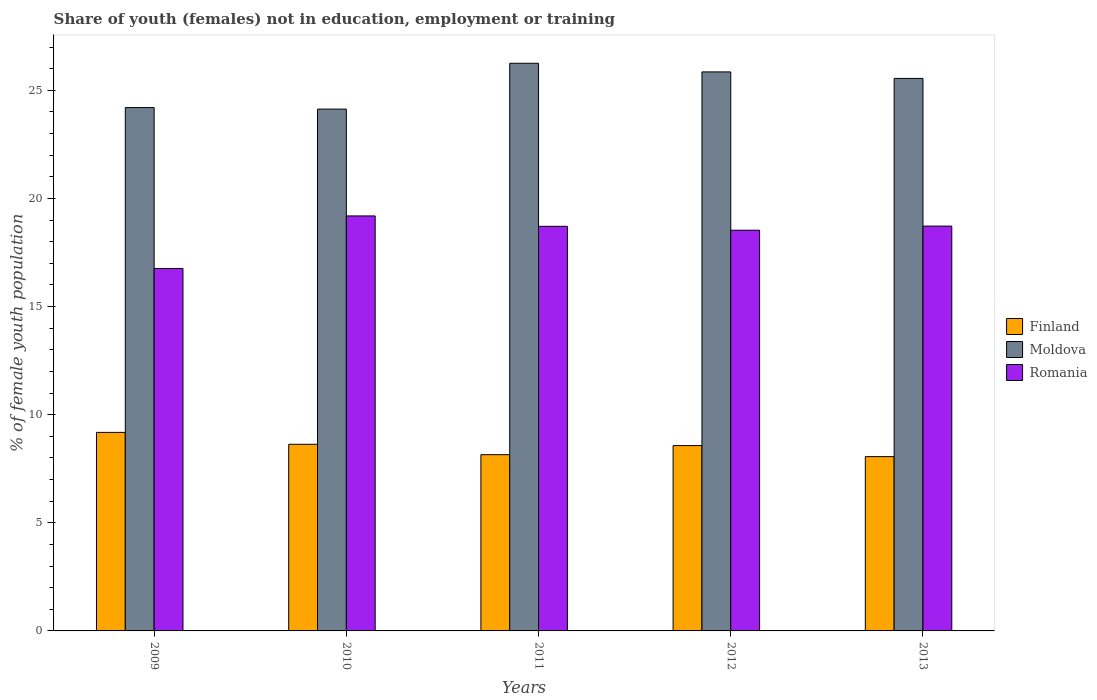How many groups of bars are there?
Your response must be concise. 5. How many bars are there on the 5th tick from the left?
Offer a terse response. 3. How many bars are there on the 3rd tick from the right?
Make the answer very short. 3. What is the percentage of unemployed female population in in Moldova in 2013?
Ensure brevity in your answer.  25.55. Across all years, what is the maximum percentage of unemployed female population in in Finland?
Offer a very short reply. 9.18. Across all years, what is the minimum percentage of unemployed female population in in Moldova?
Provide a succinct answer. 24.13. In which year was the percentage of unemployed female population in in Finland maximum?
Ensure brevity in your answer.  2009. In which year was the percentage of unemployed female population in in Moldova minimum?
Provide a short and direct response. 2010. What is the total percentage of unemployed female population in in Romania in the graph?
Provide a succinct answer. 91.91. What is the difference between the percentage of unemployed female population in in Finland in 2011 and that in 2012?
Ensure brevity in your answer.  -0.42. What is the difference between the percentage of unemployed female population in in Moldova in 2010 and the percentage of unemployed female population in in Finland in 2009?
Offer a very short reply. 14.95. What is the average percentage of unemployed female population in in Finland per year?
Offer a very short reply. 8.52. In the year 2010, what is the difference between the percentage of unemployed female population in in Romania and percentage of unemployed female population in in Moldova?
Offer a very short reply. -4.94. What is the ratio of the percentage of unemployed female population in in Finland in 2009 to that in 2012?
Keep it short and to the point. 1.07. Is the difference between the percentage of unemployed female population in in Romania in 2012 and 2013 greater than the difference between the percentage of unemployed female population in in Moldova in 2012 and 2013?
Your answer should be very brief. No. What is the difference between the highest and the second highest percentage of unemployed female population in in Romania?
Offer a terse response. 0.47. What is the difference between the highest and the lowest percentage of unemployed female population in in Romania?
Your response must be concise. 2.43. In how many years, is the percentage of unemployed female population in in Romania greater than the average percentage of unemployed female population in in Romania taken over all years?
Keep it short and to the point. 4. Is the sum of the percentage of unemployed female population in in Moldova in 2011 and 2013 greater than the maximum percentage of unemployed female population in in Romania across all years?
Provide a succinct answer. Yes. What does the 3rd bar from the right in 2012 represents?
Your answer should be very brief. Finland. Is it the case that in every year, the sum of the percentage of unemployed female population in in Romania and percentage of unemployed female population in in Moldova is greater than the percentage of unemployed female population in in Finland?
Give a very brief answer. Yes. Are all the bars in the graph horizontal?
Ensure brevity in your answer.  No. How many years are there in the graph?
Ensure brevity in your answer.  5. What is the difference between two consecutive major ticks on the Y-axis?
Provide a succinct answer. 5. Are the values on the major ticks of Y-axis written in scientific E-notation?
Give a very brief answer. No. Where does the legend appear in the graph?
Your answer should be compact. Center right. How many legend labels are there?
Offer a terse response. 3. How are the legend labels stacked?
Offer a terse response. Vertical. What is the title of the graph?
Your answer should be compact. Share of youth (females) not in education, employment or training. What is the label or title of the Y-axis?
Offer a very short reply. % of female youth population. What is the % of female youth population in Finland in 2009?
Your answer should be compact. 9.18. What is the % of female youth population of Moldova in 2009?
Give a very brief answer. 24.2. What is the % of female youth population in Romania in 2009?
Ensure brevity in your answer.  16.76. What is the % of female youth population of Finland in 2010?
Provide a succinct answer. 8.63. What is the % of female youth population in Moldova in 2010?
Your answer should be very brief. 24.13. What is the % of female youth population of Romania in 2010?
Offer a very short reply. 19.19. What is the % of female youth population of Finland in 2011?
Make the answer very short. 8.15. What is the % of female youth population of Moldova in 2011?
Your response must be concise. 26.25. What is the % of female youth population in Romania in 2011?
Give a very brief answer. 18.71. What is the % of female youth population of Finland in 2012?
Your answer should be very brief. 8.57. What is the % of female youth population of Moldova in 2012?
Offer a terse response. 25.85. What is the % of female youth population of Romania in 2012?
Keep it short and to the point. 18.53. What is the % of female youth population in Finland in 2013?
Your response must be concise. 8.06. What is the % of female youth population in Moldova in 2013?
Make the answer very short. 25.55. What is the % of female youth population in Romania in 2013?
Provide a succinct answer. 18.72. Across all years, what is the maximum % of female youth population of Finland?
Offer a terse response. 9.18. Across all years, what is the maximum % of female youth population of Moldova?
Provide a succinct answer. 26.25. Across all years, what is the maximum % of female youth population of Romania?
Keep it short and to the point. 19.19. Across all years, what is the minimum % of female youth population of Finland?
Give a very brief answer. 8.06. Across all years, what is the minimum % of female youth population in Moldova?
Provide a short and direct response. 24.13. Across all years, what is the minimum % of female youth population of Romania?
Offer a very short reply. 16.76. What is the total % of female youth population of Finland in the graph?
Keep it short and to the point. 42.59. What is the total % of female youth population in Moldova in the graph?
Your response must be concise. 125.98. What is the total % of female youth population in Romania in the graph?
Your response must be concise. 91.91. What is the difference between the % of female youth population of Finland in 2009 and that in 2010?
Your answer should be compact. 0.55. What is the difference between the % of female youth population in Moldova in 2009 and that in 2010?
Your response must be concise. 0.07. What is the difference between the % of female youth population in Romania in 2009 and that in 2010?
Your answer should be very brief. -2.43. What is the difference between the % of female youth population in Finland in 2009 and that in 2011?
Keep it short and to the point. 1.03. What is the difference between the % of female youth population in Moldova in 2009 and that in 2011?
Ensure brevity in your answer.  -2.05. What is the difference between the % of female youth population of Romania in 2009 and that in 2011?
Give a very brief answer. -1.95. What is the difference between the % of female youth population of Finland in 2009 and that in 2012?
Ensure brevity in your answer.  0.61. What is the difference between the % of female youth population of Moldova in 2009 and that in 2012?
Provide a short and direct response. -1.65. What is the difference between the % of female youth population in Romania in 2009 and that in 2012?
Make the answer very short. -1.77. What is the difference between the % of female youth population in Finland in 2009 and that in 2013?
Provide a succinct answer. 1.12. What is the difference between the % of female youth population of Moldova in 2009 and that in 2013?
Your answer should be very brief. -1.35. What is the difference between the % of female youth population of Romania in 2009 and that in 2013?
Ensure brevity in your answer.  -1.96. What is the difference between the % of female youth population in Finland in 2010 and that in 2011?
Offer a terse response. 0.48. What is the difference between the % of female youth population in Moldova in 2010 and that in 2011?
Offer a terse response. -2.12. What is the difference between the % of female youth population in Romania in 2010 and that in 2011?
Give a very brief answer. 0.48. What is the difference between the % of female youth population in Finland in 2010 and that in 2012?
Ensure brevity in your answer.  0.06. What is the difference between the % of female youth population of Moldova in 2010 and that in 2012?
Keep it short and to the point. -1.72. What is the difference between the % of female youth population in Romania in 2010 and that in 2012?
Provide a succinct answer. 0.66. What is the difference between the % of female youth population in Finland in 2010 and that in 2013?
Your answer should be very brief. 0.57. What is the difference between the % of female youth population of Moldova in 2010 and that in 2013?
Provide a succinct answer. -1.42. What is the difference between the % of female youth population of Romania in 2010 and that in 2013?
Your answer should be compact. 0.47. What is the difference between the % of female youth population in Finland in 2011 and that in 2012?
Make the answer very short. -0.42. What is the difference between the % of female youth population in Moldova in 2011 and that in 2012?
Your response must be concise. 0.4. What is the difference between the % of female youth population in Romania in 2011 and that in 2012?
Keep it short and to the point. 0.18. What is the difference between the % of female youth population of Finland in 2011 and that in 2013?
Your response must be concise. 0.09. What is the difference between the % of female youth population in Romania in 2011 and that in 2013?
Your response must be concise. -0.01. What is the difference between the % of female youth population in Finland in 2012 and that in 2013?
Your answer should be very brief. 0.51. What is the difference between the % of female youth population of Moldova in 2012 and that in 2013?
Provide a short and direct response. 0.3. What is the difference between the % of female youth population of Romania in 2012 and that in 2013?
Ensure brevity in your answer.  -0.19. What is the difference between the % of female youth population in Finland in 2009 and the % of female youth population in Moldova in 2010?
Ensure brevity in your answer.  -14.95. What is the difference between the % of female youth population of Finland in 2009 and the % of female youth population of Romania in 2010?
Ensure brevity in your answer.  -10.01. What is the difference between the % of female youth population in Moldova in 2009 and the % of female youth population in Romania in 2010?
Your answer should be compact. 5.01. What is the difference between the % of female youth population of Finland in 2009 and the % of female youth population of Moldova in 2011?
Offer a terse response. -17.07. What is the difference between the % of female youth population of Finland in 2009 and the % of female youth population of Romania in 2011?
Your response must be concise. -9.53. What is the difference between the % of female youth population in Moldova in 2009 and the % of female youth population in Romania in 2011?
Your answer should be compact. 5.49. What is the difference between the % of female youth population of Finland in 2009 and the % of female youth population of Moldova in 2012?
Provide a succinct answer. -16.67. What is the difference between the % of female youth population in Finland in 2009 and the % of female youth population in Romania in 2012?
Make the answer very short. -9.35. What is the difference between the % of female youth population of Moldova in 2009 and the % of female youth population of Romania in 2012?
Ensure brevity in your answer.  5.67. What is the difference between the % of female youth population in Finland in 2009 and the % of female youth population in Moldova in 2013?
Your answer should be compact. -16.37. What is the difference between the % of female youth population of Finland in 2009 and the % of female youth population of Romania in 2013?
Make the answer very short. -9.54. What is the difference between the % of female youth population in Moldova in 2009 and the % of female youth population in Romania in 2013?
Provide a succinct answer. 5.48. What is the difference between the % of female youth population in Finland in 2010 and the % of female youth population in Moldova in 2011?
Keep it short and to the point. -17.62. What is the difference between the % of female youth population in Finland in 2010 and the % of female youth population in Romania in 2011?
Ensure brevity in your answer.  -10.08. What is the difference between the % of female youth population in Moldova in 2010 and the % of female youth population in Romania in 2011?
Your answer should be very brief. 5.42. What is the difference between the % of female youth population in Finland in 2010 and the % of female youth population in Moldova in 2012?
Offer a very short reply. -17.22. What is the difference between the % of female youth population of Moldova in 2010 and the % of female youth population of Romania in 2012?
Ensure brevity in your answer.  5.6. What is the difference between the % of female youth population in Finland in 2010 and the % of female youth population in Moldova in 2013?
Your answer should be compact. -16.92. What is the difference between the % of female youth population of Finland in 2010 and the % of female youth population of Romania in 2013?
Make the answer very short. -10.09. What is the difference between the % of female youth population of Moldova in 2010 and the % of female youth population of Romania in 2013?
Provide a succinct answer. 5.41. What is the difference between the % of female youth population in Finland in 2011 and the % of female youth population in Moldova in 2012?
Give a very brief answer. -17.7. What is the difference between the % of female youth population in Finland in 2011 and the % of female youth population in Romania in 2012?
Your answer should be compact. -10.38. What is the difference between the % of female youth population of Moldova in 2011 and the % of female youth population of Romania in 2012?
Offer a very short reply. 7.72. What is the difference between the % of female youth population in Finland in 2011 and the % of female youth population in Moldova in 2013?
Your answer should be very brief. -17.4. What is the difference between the % of female youth population of Finland in 2011 and the % of female youth population of Romania in 2013?
Provide a succinct answer. -10.57. What is the difference between the % of female youth population in Moldova in 2011 and the % of female youth population in Romania in 2013?
Provide a succinct answer. 7.53. What is the difference between the % of female youth population of Finland in 2012 and the % of female youth population of Moldova in 2013?
Provide a short and direct response. -16.98. What is the difference between the % of female youth population in Finland in 2012 and the % of female youth population in Romania in 2013?
Ensure brevity in your answer.  -10.15. What is the difference between the % of female youth population of Moldova in 2012 and the % of female youth population of Romania in 2013?
Offer a very short reply. 7.13. What is the average % of female youth population in Finland per year?
Your response must be concise. 8.52. What is the average % of female youth population of Moldova per year?
Your answer should be very brief. 25.2. What is the average % of female youth population in Romania per year?
Ensure brevity in your answer.  18.38. In the year 2009, what is the difference between the % of female youth population of Finland and % of female youth population of Moldova?
Provide a succinct answer. -15.02. In the year 2009, what is the difference between the % of female youth population in Finland and % of female youth population in Romania?
Ensure brevity in your answer.  -7.58. In the year 2009, what is the difference between the % of female youth population in Moldova and % of female youth population in Romania?
Keep it short and to the point. 7.44. In the year 2010, what is the difference between the % of female youth population in Finland and % of female youth population in Moldova?
Provide a succinct answer. -15.5. In the year 2010, what is the difference between the % of female youth population in Finland and % of female youth population in Romania?
Provide a short and direct response. -10.56. In the year 2010, what is the difference between the % of female youth population of Moldova and % of female youth population of Romania?
Give a very brief answer. 4.94. In the year 2011, what is the difference between the % of female youth population of Finland and % of female youth population of Moldova?
Make the answer very short. -18.1. In the year 2011, what is the difference between the % of female youth population in Finland and % of female youth population in Romania?
Your answer should be very brief. -10.56. In the year 2011, what is the difference between the % of female youth population in Moldova and % of female youth population in Romania?
Your response must be concise. 7.54. In the year 2012, what is the difference between the % of female youth population of Finland and % of female youth population of Moldova?
Give a very brief answer. -17.28. In the year 2012, what is the difference between the % of female youth population of Finland and % of female youth population of Romania?
Your answer should be very brief. -9.96. In the year 2012, what is the difference between the % of female youth population in Moldova and % of female youth population in Romania?
Provide a succinct answer. 7.32. In the year 2013, what is the difference between the % of female youth population in Finland and % of female youth population in Moldova?
Provide a short and direct response. -17.49. In the year 2013, what is the difference between the % of female youth population of Finland and % of female youth population of Romania?
Your answer should be compact. -10.66. In the year 2013, what is the difference between the % of female youth population in Moldova and % of female youth population in Romania?
Ensure brevity in your answer.  6.83. What is the ratio of the % of female youth population of Finland in 2009 to that in 2010?
Offer a terse response. 1.06. What is the ratio of the % of female youth population in Moldova in 2009 to that in 2010?
Your answer should be compact. 1. What is the ratio of the % of female youth population of Romania in 2009 to that in 2010?
Your answer should be compact. 0.87. What is the ratio of the % of female youth population in Finland in 2009 to that in 2011?
Provide a succinct answer. 1.13. What is the ratio of the % of female youth population in Moldova in 2009 to that in 2011?
Offer a terse response. 0.92. What is the ratio of the % of female youth population in Romania in 2009 to that in 2011?
Provide a short and direct response. 0.9. What is the ratio of the % of female youth population of Finland in 2009 to that in 2012?
Make the answer very short. 1.07. What is the ratio of the % of female youth population in Moldova in 2009 to that in 2012?
Provide a succinct answer. 0.94. What is the ratio of the % of female youth population of Romania in 2009 to that in 2012?
Offer a very short reply. 0.9. What is the ratio of the % of female youth population in Finland in 2009 to that in 2013?
Ensure brevity in your answer.  1.14. What is the ratio of the % of female youth population in Moldova in 2009 to that in 2013?
Offer a terse response. 0.95. What is the ratio of the % of female youth population in Romania in 2009 to that in 2013?
Your answer should be very brief. 0.9. What is the ratio of the % of female youth population in Finland in 2010 to that in 2011?
Ensure brevity in your answer.  1.06. What is the ratio of the % of female youth population in Moldova in 2010 to that in 2011?
Give a very brief answer. 0.92. What is the ratio of the % of female youth population in Romania in 2010 to that in 2011?
Your answer should be very brief. 1.03. What is the ratio of the % of female youth population in Moldova in 2010 to that in 2012?
Your answer should be very brief. 0.93. What is the ratio of the % of female youth population of Romania in 2010 to that in 2012?
Provide a short and direct response. 1.04. What is the ratio of the % of female youth population of Finland in 2010 to that in 2013?
Offer a very short reply. 1.07. What is the ratio of the % of female youth population of Moldova in 2010 to that in 2013?
Your answer should be very brief. 0.94. What is the ratio of the % of female youth population in Romania in 2010 to that in 2013?
Your answer should be compact. 1.03. What is the ratio of the % of female youth population of Finland in 2011 to that in 2012?
Keep it short and to the point. 0.95. What is the ratio of the % of female youth population of Moldova in 2011 to that in 2012?
Keep it short and to the point. 1.02. What is the ratio of the % of female youth population of Romania in 2011 to that in 2012?
Provide a short and direct response. 1.01. What is the ratio of the % of female youth population of Finland in 2011 to that in 2013?
Ensure brevity in your answer.  1.01. What is the ratio of the % of female youth population of Moldova in 2011 to that in 2013?
Provide a succinct answer. 1.03. What is the ratio of the % of female youth population in Finland in 2012 to that in 2013?
Your response must be concise. 1.06. What is the ratio of the % of female youth population of Moldova in 2012 to that in 2013?
Offer a very short reply. 1.01. What is the difference between the highest and the second highest % of female youth population of Finland?
Provide a short and direct response. 0.55. What is the difference between the highest and the second highest % of female youth population of Romania?
Make the answer very short. 0.47. What is the difference between the highest and the lowest % of female youth population in Finland?
Your answer should be compact. 1.12. What is the difference between the highest and the lowest % of female youth population in Moldova?
Offer a terse response. 2.12. What is the difference between the highest and the lowest % of female youth population of Romania?
Give a very brief answer. 2.43. 